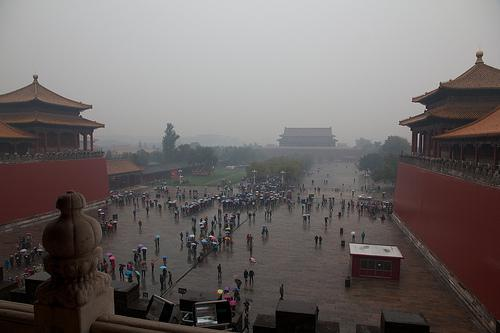Question: who is gathered in the square?
Choices:
A. Protesters.
B. Children.
C. Union members.
D. People.
Answer with the letter. Answer: D Question: what kind of weather is it?
Choices:
A. Sunny.
B. Cloudy.
C. Breezy.
D. Foggy.
Answer with the letter. Answer: D Question: when will they put away their umbrellas?
Choices:
A. When they go inside.
B. When they get in the car.
C. When it stops raining.
D. When they get on the bus.
Answer with the letter. Answer: C Question: what color are the walls?
Choices:
A. Yellow.
B. White.
C. Red.
D. Brown.
Answer with the letter. Answer: C Question: what kind of architecture is it?
Choices:
A. Asian.
B. Ancient roman.
C. Greek.
D. French.
Answer with the letter. Answer: A Question: why do they have umbrellas?
Choices:
A. To shield from the sun.
B. Because it is raining.
C. Because it is supposed to rain.
D. Because it stopped raining.
Answer with the letter. Answer: B 